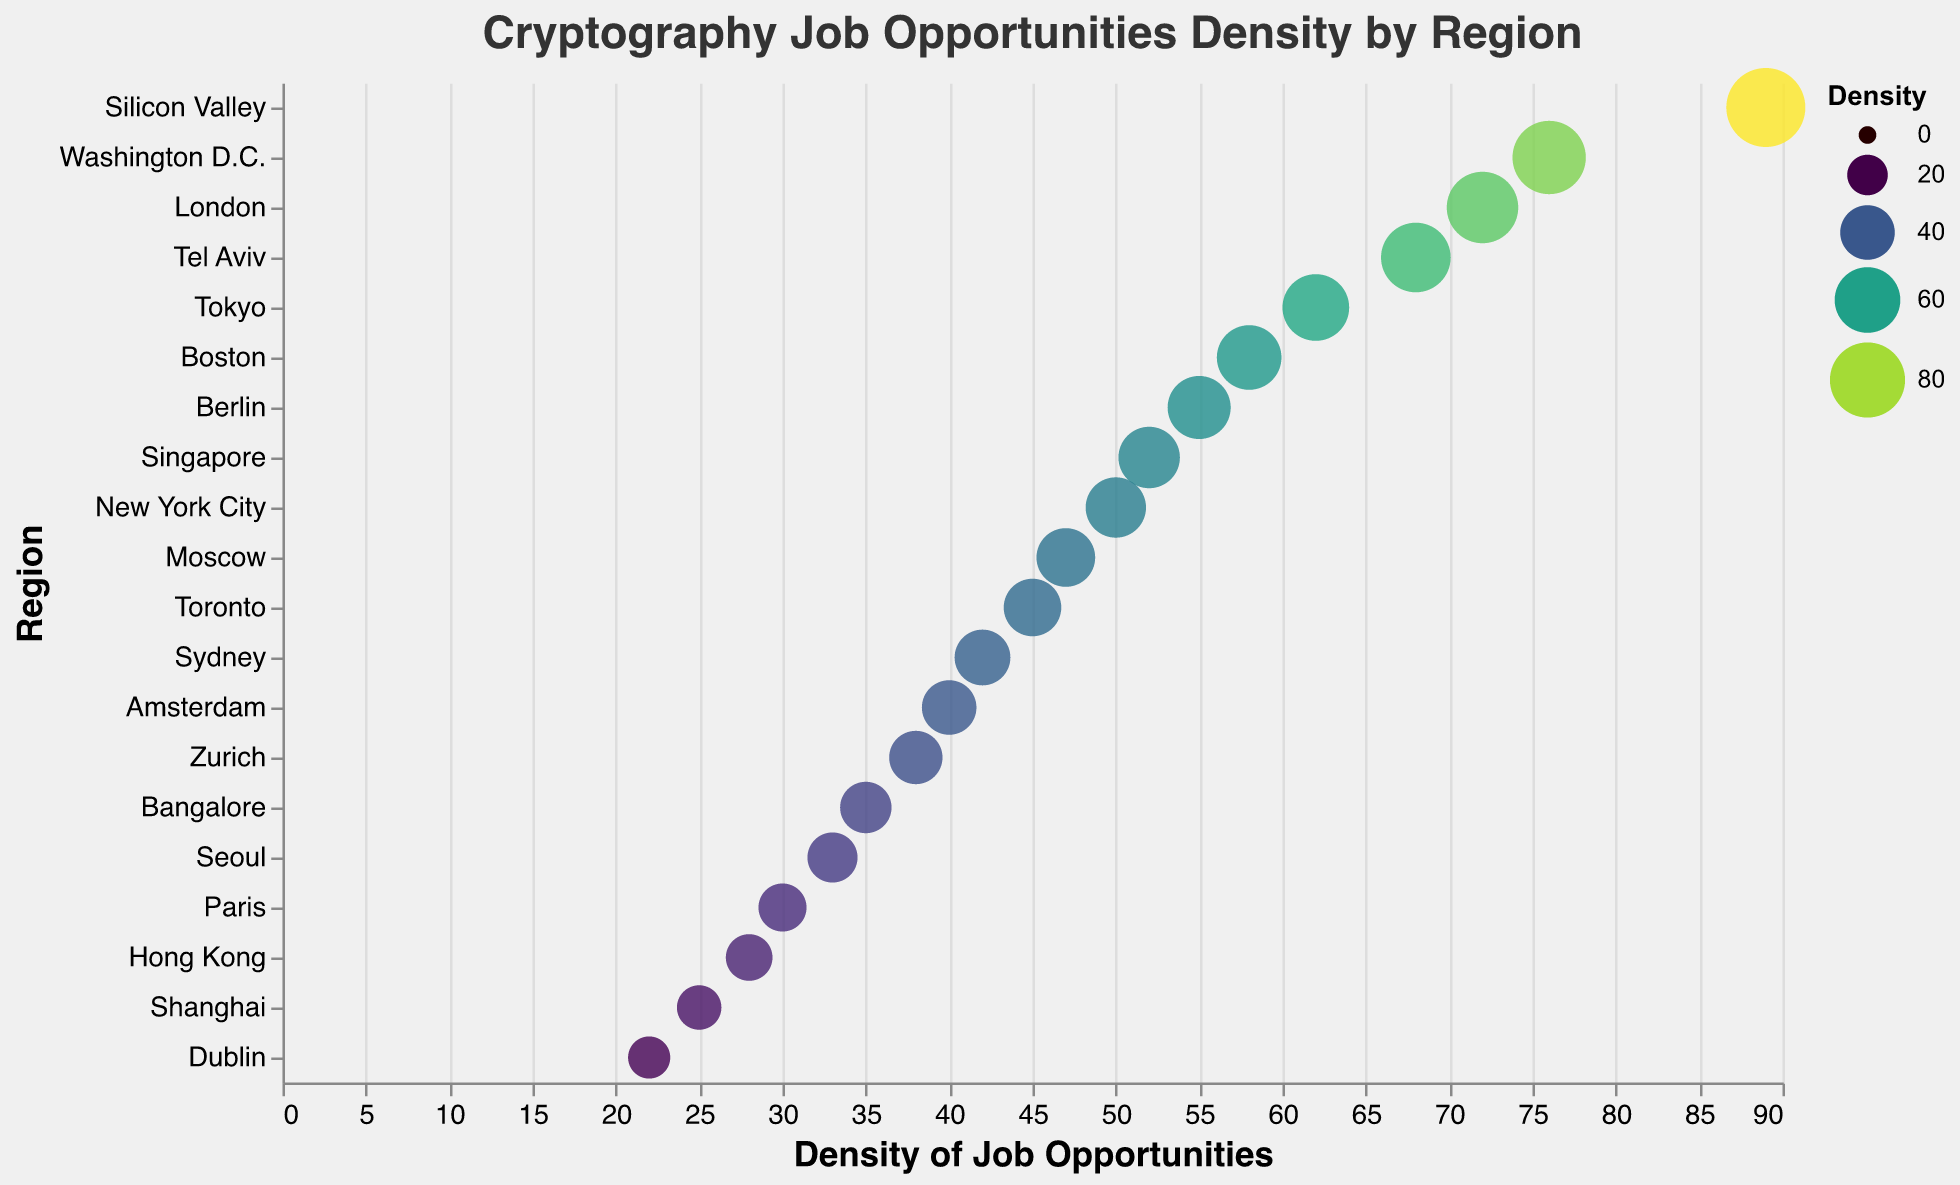What is the region with the highest density of cryptography job opportunities? The region with the highest density of cryptography-related job opportunities can be identified as having the largest circle, which is labeled "Silicon Valley" with a density value of 89.
Answer: Silicon Valley How many regions have a density value greater than 50? To determine this, count all the regions where the density value is more than 50. The regions are Silicon Valley, Washington D.C., London, Tel Aviv, Tokyo, Boston, Berlin, Singapore, and New York City.
Answer: 9 What is the difference in job opportunity density between Silicon Valley and Dublin? Identify the density values for Silicon Valley (89) and Dublin (22), then compute the difference. 89 - 22 = 67.
Answer: 67 Which region has a higher density of job opportunities, Moscow or Amsterdam? Compare the density values for Moscow (47) and Amsterdam (40). Moscow has a higher density.
Answer: Moscow What is the median density value for all the regions? First, list all density values in ascending order: 22, 25, 28, 30, 33, 35, 38, 40, 42, 45, 47, 50, 52, 55, 58, 62, 68, 72, 76, 89. The middle value (or average of the two middle values if even number of data points) is the median. The median value for 20 data points (average of 10th and 11th in the sorted list) is (45 + 47)/2 = 46.
Answer: 46 What is the average density of cryptography-related job opportunities across all regions? Sum all the density values (22 + 25 + 28 + 30 + 33 + 35 + 38 + 40 + 42 + 45 + 47 + 50 + 52 + 55 + 58 + 62 + 68 + 72 + 76 + 89) which is 937. The average is 937 / 20 = 46.85.
Answer: 46.85 How does the density of job opportunities in Tel Aviv compare to that in Tokyo? Identify the density values for Tel Aviv (68) and Tokyo (62). Tel Aviv has a higher density than Tokyo.
Answer: Tel Aviv What is the ratio of the density of job opportunities in London to that in Berlin? The density value for London is 72 and that for Berlin is 55. The ratio is 72 / 55, which simplifies to approximately 1.31.
Answer: 1.31 Which region shows the lowest density of cryptography job opportunities? Identify the region with the smallest circle labeled with the lowest density value, which is "Dublin" (22).
Answer: Dublin 